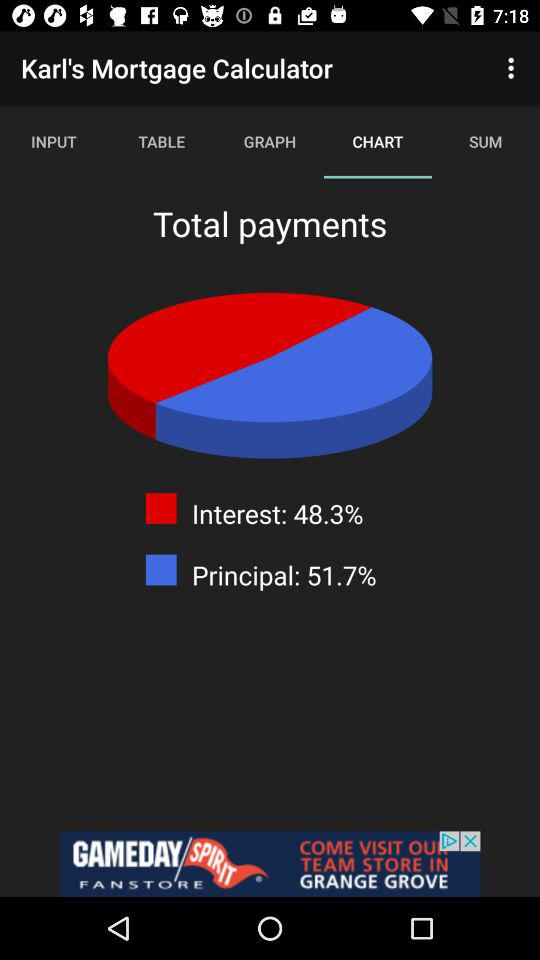What is the principal percentage? The principal percentage is 51.7. 